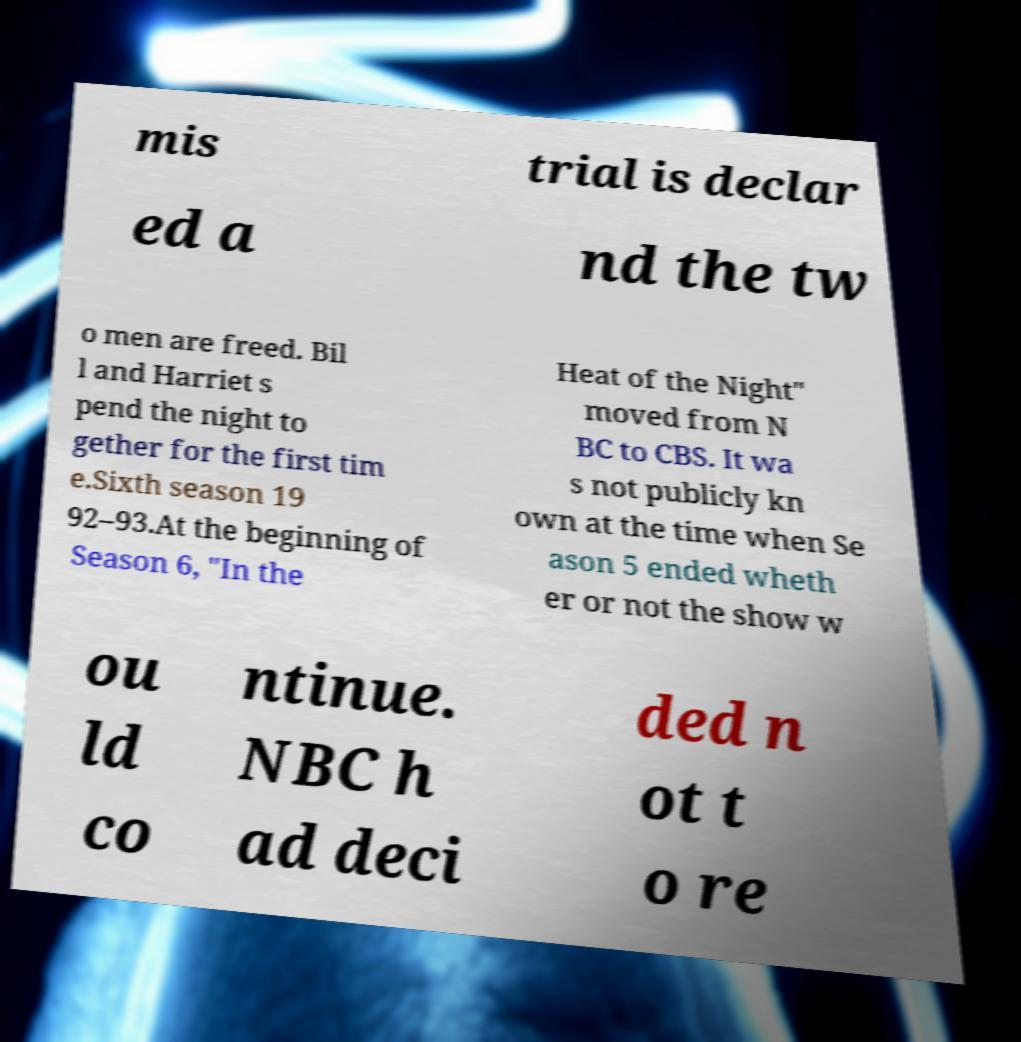Could you assist in decoding the text presented in this image and type it out clearly? mis trial is declar ed a nd the tw o men are freed. Bil l and Harriet s pend the night to gether for the first tim e.Sixth season 19 92–93.At the beginning of Season 6, "In the Heat of the Night" moved from N BC to CBS. It wa s not publicly kn own at the time when Se ason 5 ended wheth er or not the show w ou ld co ntinue. NBC h ad deci ded n ot t o re 